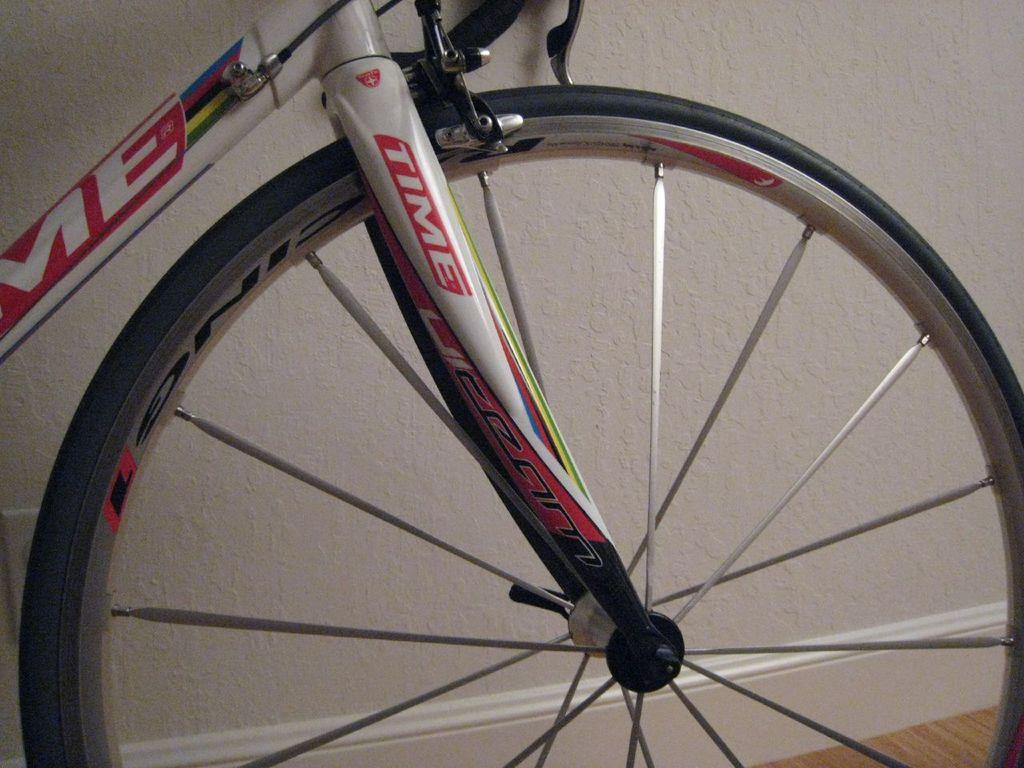What is the main object in the foreground of the image? There is a tire of a cycle in the foreground of the image. What can be seen in the background of the image? There is a wall and a surface visible in the background of the image. How many goats are climbing on the wall in the image? There are no goats present in the image; it only features a tire of a cycle in the foreground and a wall and surface in the background. 